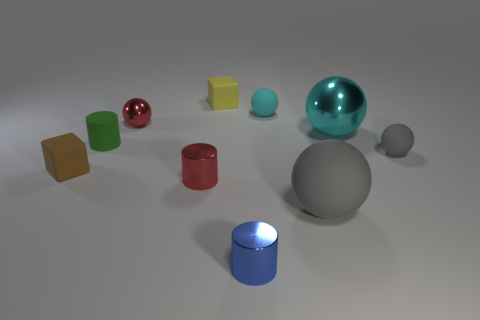Subtract all tiny spheres. How many spheres are left? 2 Subtract all cyan cylinders. How many gray balls are left? 2 Subtract all cyan balls. How many balls are left? 3 Subtract all blue spheres. Subtract all yellow blocks. How many spheres are left? 5 Subtract all gray spheres. Subtract all large cyan shiny spheres. How many objects are left? 7 Add 6 cyan metallic things. How many cyan metallic things are left? 7 Add 2 cyan matte things. How many cyan matte things exist? 3 Subtract 0 blue cubes. How many objects are left? 10 Subtract all blocks. How many objects are left? 8 